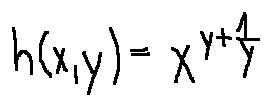Convert formula to latex. <formula><loc_0><loc_0><loc_500><loc_500>h ( x , y ) = x ^ { y + \frac { 1 } { y } }</formula> 